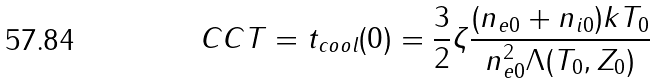Convert formula to latex. <formula><loc_0><loc_0><loc_500><loc_500>C C T = t _ { c o o l } ( 0 ) = \frac { 3 } { 2 } \zeta \frac { ( n _ { e 0 } + n _ { i 0 } ) k T _ { 0 } } { { n } ^ { 2 } _ { e 0 } \Lambda ( T _ { 0 } , Z _ { 0 } ) }</formula> 